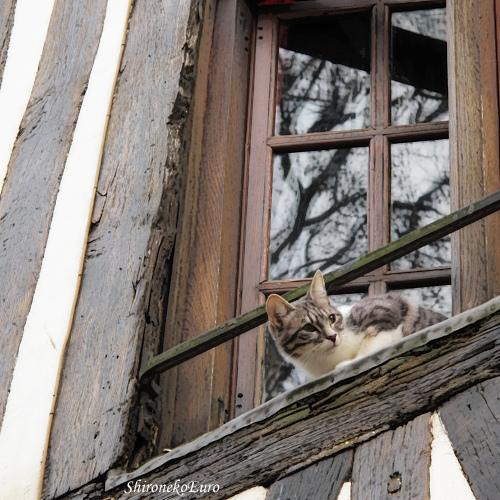How many eyes does this animal have?
Quick response, please. 2. Does this appear to be a new or old building?
Keep it brief. Old. Is the cat jumping?
Be succinct. No. 